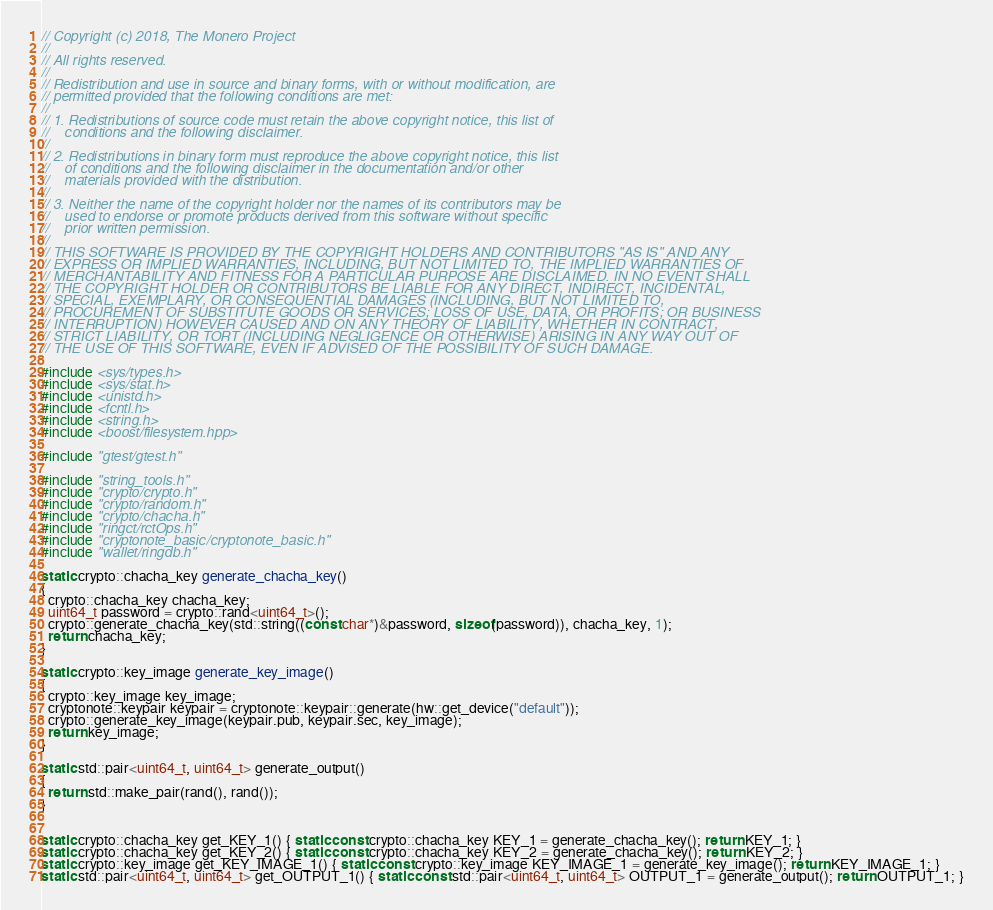<code> <loc_0><loc_0><loc_500><loc_500><_C++_>// Copyright (c) 2018, The Monero Project
// 
// All rights reserved.
// 
// Redistribution and use in source and binary forms, with or without modification, are
// permitted provided that the following conditions are met:
// 
// 1. Redistributions of source code must retain the above copyright notice, this list of
//    conditions and the following disclaimer.
// 
// 2. Redistributions in binary form must reproduce the above copyright notice, this list
//    of conditions and the following disclaimer in the documentation and/or other
//    materials provided with the distribution.
// 
// 3. Neither the name of the copyright holder nor the names of its contributors may be
//    used to endorse or promote products derived from this software without specific
//    prior written permission.
// 
// THIS SOFTWARE IS PROVIDED BY THE COPYRIGHT HOLDERS AND CONTRIBUTORS "AS IS" AND ANY
// EXPRESS OR IMPLIED WARRANTIES, INCLUDING, BUT NOT LIMITED TO, THE IMPLIED WARRANTIES OF
// MERCHANTABILITY AND FITNESS FOR A PARTICULAR PURPOSE ARE DISCLAIMED. IN NO EVENT SHALL
// THE COPYRIGHT HOLDER OR CONTRIBUTORS BE LIABLE FOR ANY DIRECT, INDIRECT, INCIDENTAL,
// SPECIAL, EXEMPLARY, OR CONSEQUENTIAL DAMAGES (INCLUDING, BUT NOT LIMITED TO,
// PROCUREMENT OF SUBSTITUTE GOODS OR SERVICES; LOSS OF USE, DATA, OR PROFITS; OR BUSINESS
// INTERRUPTION) HOWEVER CAUSED AND ON ANY THEORY OF LIABILITY, WHETHER IN CONTRACT,
// STRICT LIABILITY, OR TORT (INCLUDING NEGLIGENCE OR OTHERWISE) ARISING IN ANY WAY OUT OF
// THE USE OF THIS SOFTWARE, EVEN IF ADVISED OF THE POSSIBILITY OF SUCH DAMAGE.

#include <sys/types.h>
#include <sys/stat.h>
#include <unistd.h>
#include <fcntl.h>
#include <string.h>
#include <boost/filesystem.hpp>

#include "gtest/gtest.h"

#include "string_tools.h"
#include "crypto/crypto.h"
#include "crypto/random.h"
#include "crypto/chacha.h"
#include "ringct/rctOps.h"
#include "cryptonote_basic/cryptonote_basic.h"
#include "wallet/ringdb.h"

static crypto::chacha_key generate_chacha_key()
{
  crypto::chacha_key chacha_key;
  uint64_t password = crypto::rand<uint64_t>();
  crypto::generate_chacha_key(std::string((const char*)&password, sizeof(password)), chacha_key, 1);
  return chacha_key;
}

static crypto::key_image generate_key_image()
{
  crypto::key_image key_image;
  cryptonote::keypair keypair = cryptonote::keypair::generate(hw::get_device("default"));
  crypto::generate_key_image(keypair.pub, keypair.sec, key_image);
  return key_image;
}

static std::pair<uint64_t, uint64_t> generate_output()
{
  return std::make_pair(rand(), rand());
}


static crypto::chacha_key get_KEY_1() { static const crypto::chacha_key KEY_1 = generate_chacha_key(); return KEY_1; }
static crypto::chacha_key get_KEY_2() { static const crypto::chacha_key KEY_2 = generate_chacha_key(); return KEY_2; }
static crypto::key_image get_KEY_IMAGE_1() { static const crypto::key_image KEY_IMAGE_1 = generate_key_image(); return KEY_IMAGE_1; }
static std::pair<uint64_t, uint64_t> get_OUTPUT_1() { static const std::pair<uint64_t, uint64_t> OUTPUT_1 = generate_output(); return OUTPUT_1; }</code> 